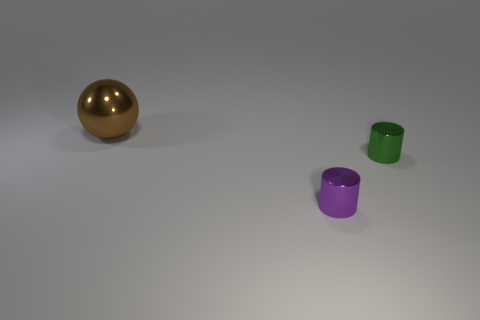Are there any small yellow objects that have the same material as the green cylinder? No, there are no small yellow objects with the same material as the green cylinder. In the image, there are three objects: a gold sphere, a green cylinder, and a purple cylinder, all of which display different colors and appear to have different surface textures. 